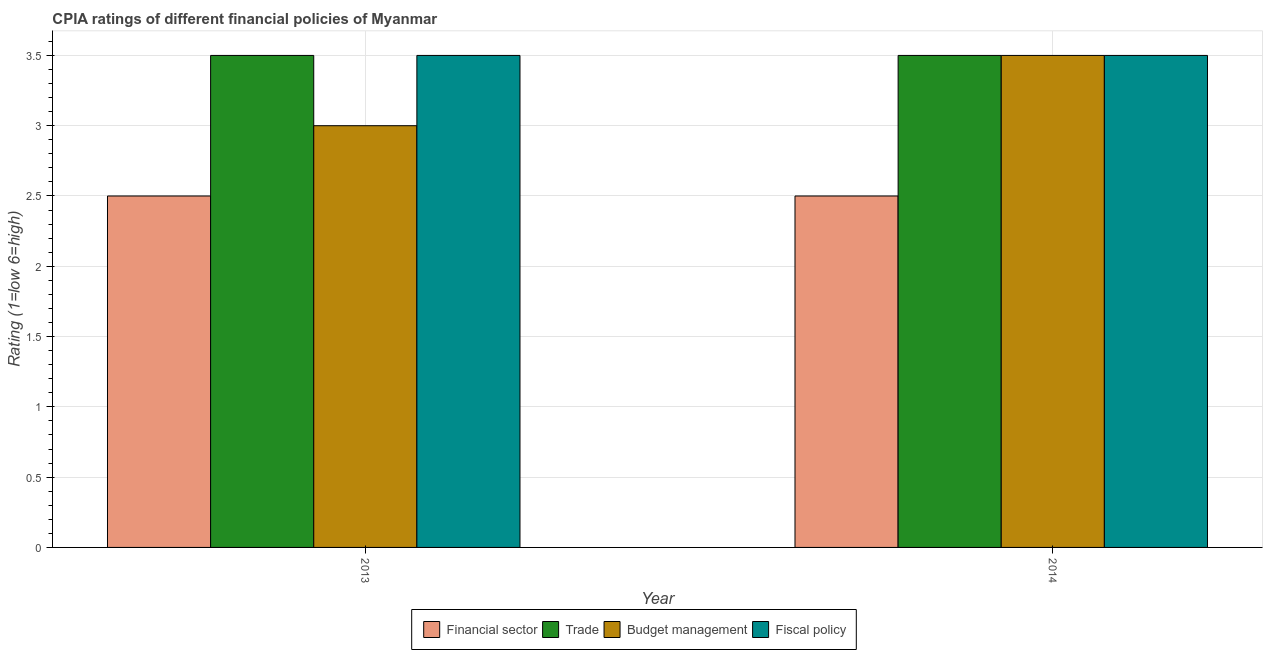How many groups of bars are there?
Provide a short and direct response. 2. Are the number of bars on each tick of the X-axis equal?
Provide a short and direct response. Yes. How many bars are there on the 1st tick from the left?
Make the answer very short. 4. How many bars are there on the 2nd tick from the right?
Your response must be concise. 4. What is the cpia rating of budget management in 2013?
Provide a succinct answer. 3. In which year was the cpia rating of trade maximum?
Keep it short and to the point. 2013. In which year was the cpia rating of fiscal policy minimum?
Offer a terse response. 2013. What is the difference between the cpia rating of trade in 2013 and that in 2014?
Your answer should be very brief. 0. What is the average cpia rating of financial sector per year?
Your response must be concise. 2.5. In the year 2013, what is the difference between the cpia rating of financial sector and cpia rating of trade?
Keep it short and to the point. 0. In how many years, is the cpia rating of budget management greater than 3.1?
Make the answer very short. 1. What is the ratio of the cpia rating of budget management in 2013 to that in 2014?
Provide a succinct answer. 0.86. In how many years, is the cpia rating of financial sector greater than the average cpia rating of financial sector taken over all years?
Provide a short and direct response. 0. What does the 3rd bar from the left in 2013 represents?
Ensure brevity in your answer.  Budget management. What does the 4th bar from the right in 2013 represents?
Keep it short and to the point. Financial sector. Where does the legend appear in the graph?
Your answer should be compact. Bottom center. How many legend labels are there?
Your answer should be very brief. 4. How are the legend labels stacked?
Provide a short and direct response. Horizontal. What is the title of the graph?
Your answer should be very brief. CPIA ratings of different financial policies of Myanmar. Does "Business regulatory environment" appear as one of the legend labels in the graph?
Provide a succinct answer. No. What is the label or title of the X-axis?
Provide a short and direct response. Year. What is the Rating (1=low 6=high) of Fiscal policy in 2013?
Your answer should be very brief. 3.5. What is the Rating (1=low 6=high) in Financial sector in 2014?
Offer a terse response. 2.5. Across all years, what is the maximum Rating (1=low 6=high) of Trade?
Your response must be concise. 3.5. Across all years, what is the maximum Rating (1=low 6=high) in Budget management?
Ensure brevity in your answer.  3.5. Across all years, what is the maximum Rating (1=low 6=high) in Fiscal policy?
Provide a succinct answer. 3.5. Across all years, what is the minimum Rating (1=low 6=high) of Fiscal policy?
Provide a succinct answer. 3.5. What is the total Rating (1=low 6=high) in Financial sector in the graph?
Offer a terse response. 5. What is the total Rating (1=low 6=high) of Fiscal policy in the graph?
Provide a succinct answer. 7. What is the difference between the Rating (1=low 6=high) in Trade in 2013 and that in 2014?
Give a very brief answer. 0. What is the difference between the Rating (1=low 6=high) of Budget management in 2013 and that in 2014?
Give a very brief answer. -0.5. What is the difference between the Rating (1=low 6=high) in Financial sector in 2013 and the Rating (1=low 6=high) in Trade in 2014?
Provide a succinct answer. -1. What is the difference between the Rating (1=low 6=high) in Financial sector in 2013 and the Rating (1=low 6=high) in Budget management in 2014?
Make the answer very short. -1. What is the difference between the Rating (1=low 6=high) of Trade in 2013 and the Rating (1=low 6=high) of Budget management in 2014?
Provide a short and direct response. 0. What is the difference between the Rating (1=low 6=high) of Trade in 2013 and the Rating (1=low 6=high) of Fiscal policy in 2014?
Offer a terse response. 0. What is the difference between the Rating (1=low 6=high) in Budget management in 2013 and the Rating (1=low 6=high) in Fiscal policy in 2014?
Your response must be concise. -0.5. In the year 2013, what is the difference between the Rating (1=low 6=high) in Financial sector and Rating (1=low 6=high) in Trade?
Offer a very short reply. -1. In the year 2013, what is the difference between the Rating (1=low 6=high) of Trade and Rating (1=low 6=high) of Fiscal policy?
Offer a terse response. 0. In the year 2013, what is the difference between the Rating (1=low 6=high) in Budget management and Rating (1=low 6=high) in Fiscal policy?
Provide a short and direct response. -0.5. In the year 2014, what is the difference between the Rating (1=low 6=high) in Financial sector and Rating (1=low 6=high) in Budget management?
Offer a terse response. -1. In the year 2014, what is the difference between the Rating (1=low 6=high) in Trade and Rating (1=low 6=high) in Budget management?
Make the answer very short. 0. In the year 2014, what is the difference between the Rating (1=low 6=high) of Budget management and Rating (1=low 6=high) of Fiscal policy?
Keep it short and to the point. 0. What is the ratio of the Rating (1=low 6=high) of Financial sector in 2013 to that in 2014?
Ensure brevity in your answer.  1. What is the ratio of the Rating (1=low 6=high) of Trade in 2013 to that in 2014?
Ensure brevity in your answer.  1. What is the ratio of the Rating (1=low 6=high) of Budget management in 2013 to that in 2014?
Your answer should be compact. 0.86. What is the ratio of the Rating (1=low 6=high) in Fiscal policy in 2013 to that in 2014?
Offer a terse response. 1. What is the difference between the highest and the second highest Rating (1=low 6=high) of Financial sector?
Make the answer very short. 0. What is the difference between the highest and the lowest Rating (1=low 6=high) in Trade?
Provide a succinct answer. 0. What is the difference between the highest and the lowest Rating (1=low 6=high) of Budget management?
Your answer should be very brief. 0.5. 